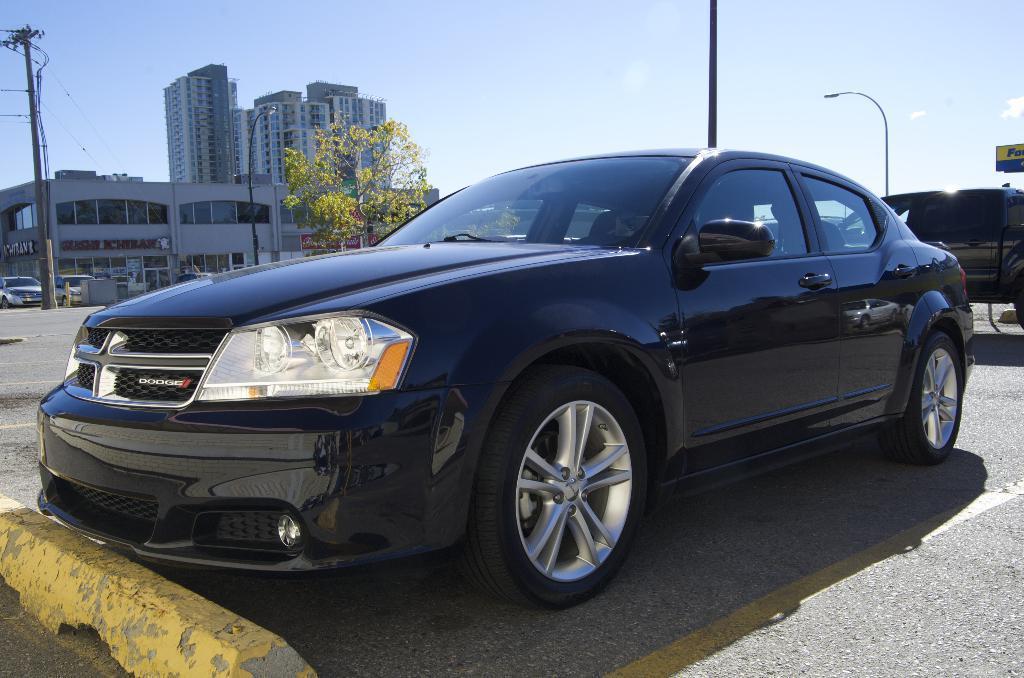Could you give a brief overview of what you see in this image? This image is taken outdoors. At the bottom of the image there is a road. In the middle of the image a car is parked on the road. On the right side of the image there is a board with a text on it and a car is parked on the road. There is a street light. At the top of the image there is a sky with clouds. On the left side of the image a few cars are parked on the road and there are two poles and a few buildings with walls, windows, roofs, doors and a few boards with text on them. 